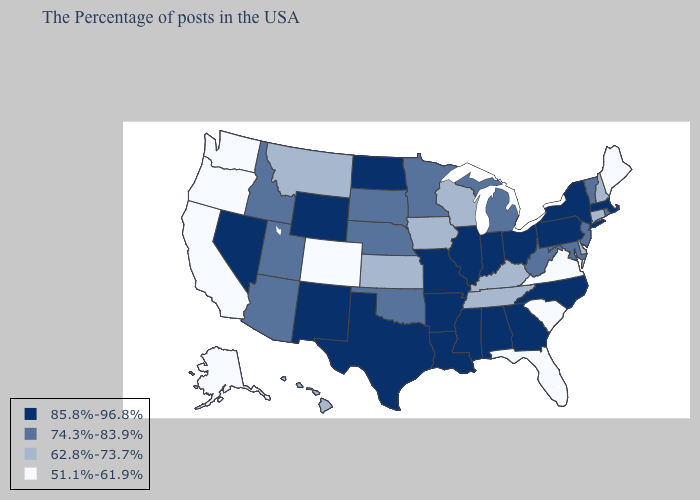Name the states that have a value in the range 85.8%-96.8%?
Concise answer only. Massachusetts, New York, Pennsylvania, North Carolina, Ohio, Georgia, Indiana, Alabama, Illinois, Mississippi, Louisiana, Missouri, Arkansas, Texas, North Dakota, Wyoming, New Mexico, Nevada. Among the states that border Wisconsin , which have the lowest value?
Give a very brief answer. Iowa. Which states have the highest value in the USA?
Short answer required. Massachusetts, New York, Pennsylvania, North Carolina, Ohio, Georgia, Indiana, Alabama, Illinois, Mississippi, Louisiana, Missouri, Arkansas, Texas, North Dakota, Wyoming, New Mexico, Nevada. What is the lowest value in states that border New Jersey?
Quick response, please. 62.8%-73.7%. What is the lowest value in the South?
Keep it brief. 51.1%-61.9%. Name the states that have a value in the range 62.8%-73.7%?
Short answer required. New Hampshire, Connecticut, Delaware, Kentucky, Tennessee, Wisconsin, Iowa, Kansas, Montana, Hawaii. Name the states that have a value in the range 74.3%-83.9%?
Give a very brief answer. Rhode Island, Vermont, New Jersey, Maryland, West Virginia, Michigan, Minnesota, Nebraska, Oklahoma, South Dakota, Utah, Arizona, Idaho. Name the states that have a value in the range 85.8%-96.8%?
Short answer required. Massachusetts, New York, Pennsylvania, North Carolina, Ohio, Georgia, Indiana, Alabama, Illinois, Mississippi, Louisiana, Missouri, Arkansas, Texas, North Dakota, Wyoming, New Mexico, Nevada. What is the highest value in states that border Washington?
Give a very brief answer. 74.3%-83.9%. Does the first symbol in the legend represent the smallest category?
Answer briefly. No. What is the value of Wisconsin?
Be succinct. 62.8%-73.7%. What is the lowest value in the USA?
Answer briefly. 51.1%-61.9%. Among the states that border North Dakota , which have the lowest value?
Write a very short answer. Montana. Does the first symbol in the legend represent the smallest category?
Short answer required. No. 